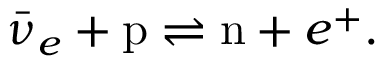Convert formula to latex. <formula><loc_0><loc_0><loc_500><loc_500>\bar { \nu } _ { e } + p \rightleftharpoons n + e ^ { + } .</formula> 